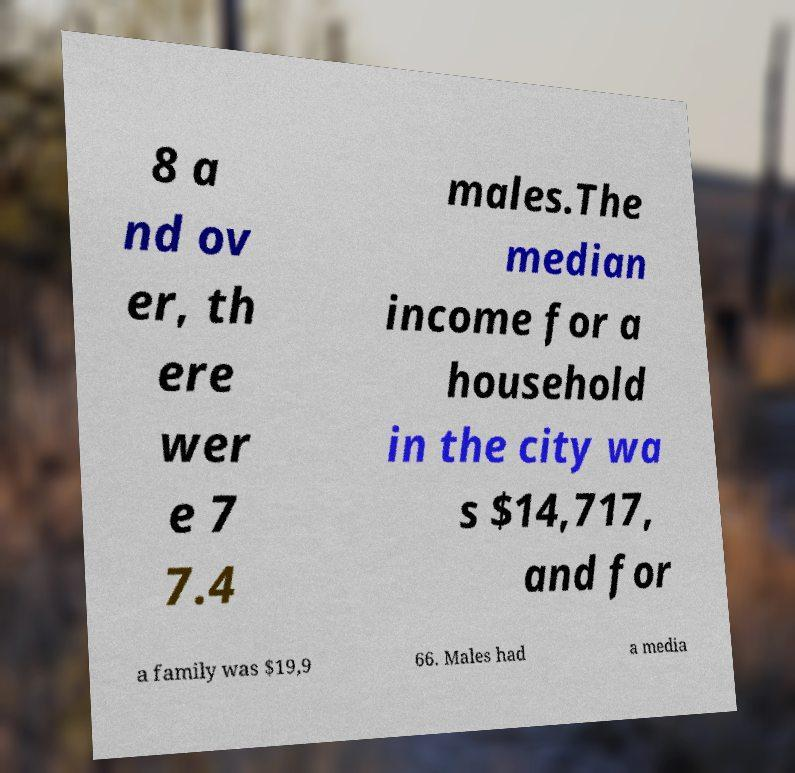For documentation purposes, I need the text within this image transcribed. Could you provide that? 8 a nd ov er, th ere wer e 7 7.4 males.The median income for a household in the city wa s $14,717, and for a family was $19,9 66. Males had a media 